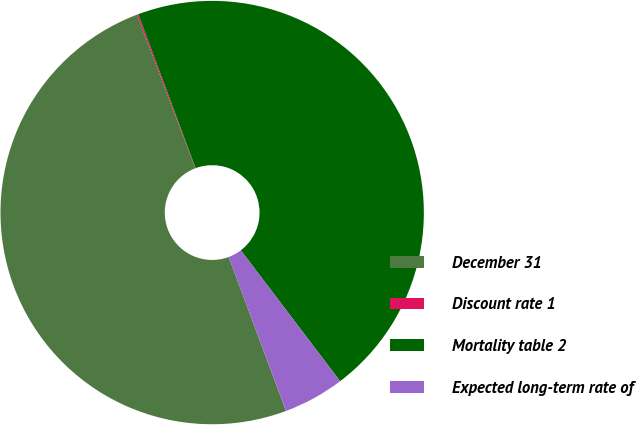Convert chart. <chart><loc_0><loc_0><loc_500><loc_500><pie_chart><fcel>December 31<fcel>Discount rate 1<fcel>Mortality table 2<fcel>Expected long-term rate of<nl><fcel>49.89%<fcel>0.11%<fcel>45.34%<fcel>4.66%<nl></chart> 